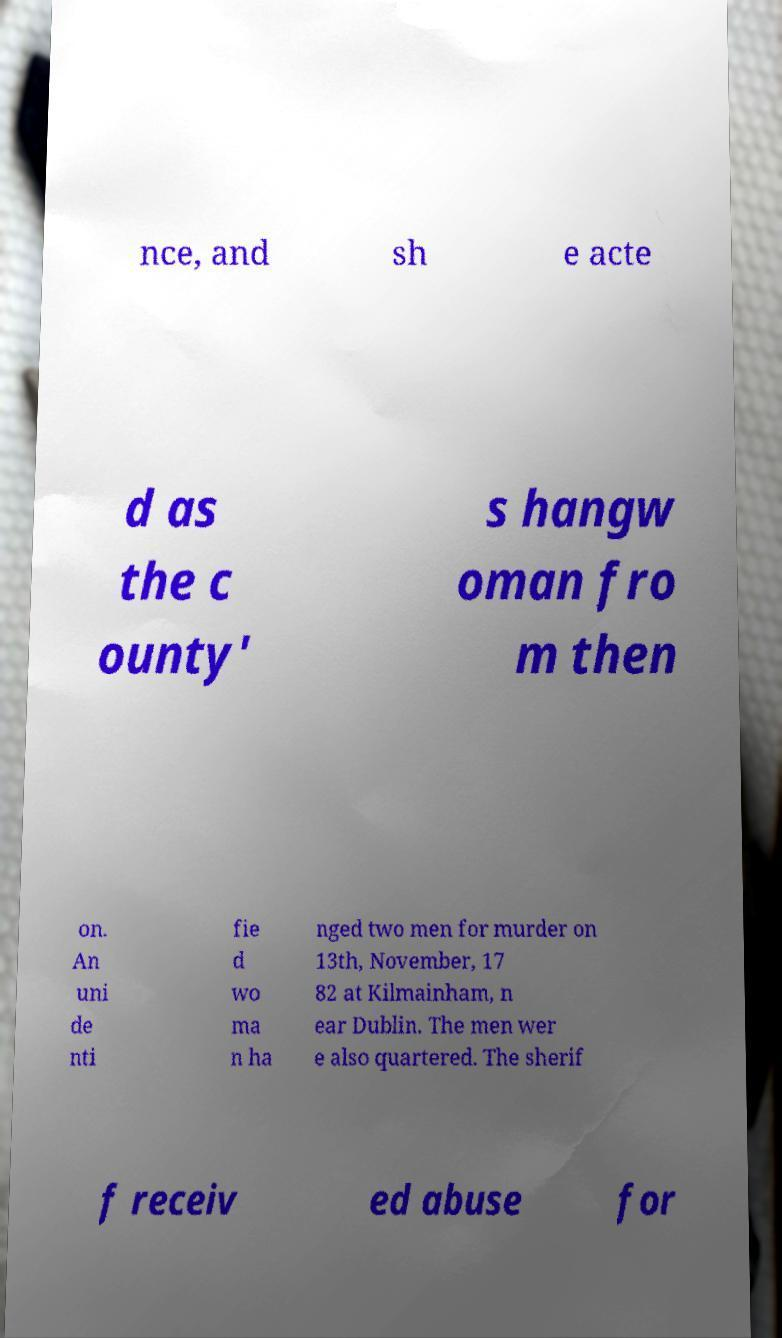Could you extract and type out the text from this image? nce, and sh e acte d as the c ounty' s hangw oman fro m then on. An uni de nti fie d wo ma n ha nged two men for murder on 13th, November, 17 82 at Kilmainham, n ear Dublin. The men wer e also quartered. The sherif f receiv ed abuse for 